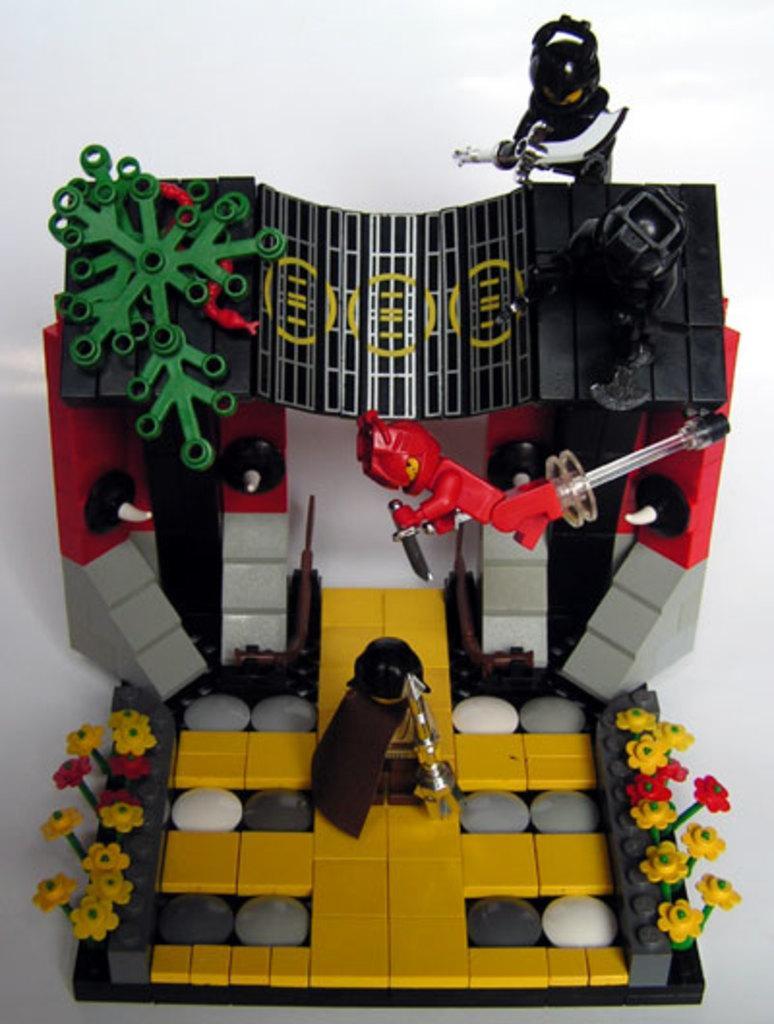Please provide a concise description of this image. In this picture, we see the Lego figures and the toys in green, red, yellow, grey and black color. In the background, it is white in color. 